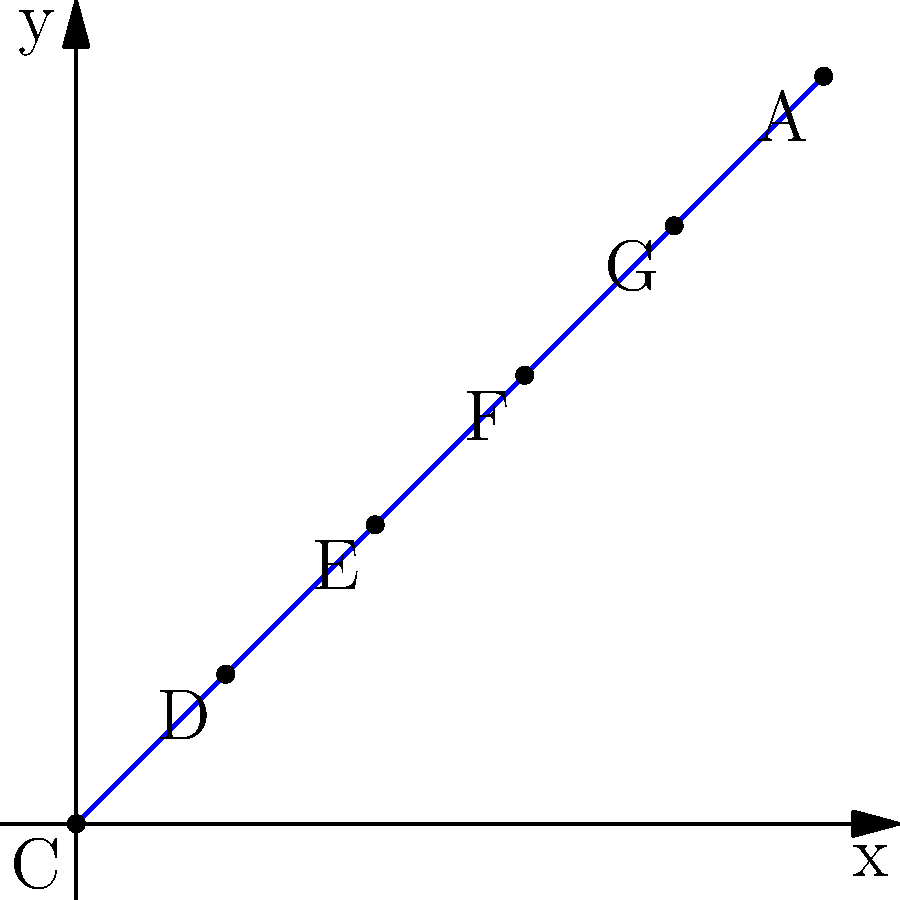Onyeka Onwenu's hit song "One Love" is represented by a polynomial equation whose roots correspond to musical notes on a staff. If the roots of the polynomial are represented by the points on the graph, and each consecutive note is one semitone apart, which of Onyeka's songs would have a polynomial with roots corresponding to the notes C, E, and G? To solve this problem, we need to follow these steps:

1) First, we need to understand the graph. The x-axis represents the position of the note, and the y-axis represents the pitch.

2) We can see that the notes are arranged in order: C, D, E, F, G, A.

3) The question asks for a polynomial with roots at C, E, and G. On the graph, these correspond to the points (0,0), (2,2), and (4,4).

4) In musical terms, the interval between C and E is a major third (4 semitones), and the interval between E and G is a minor third (3 semitones). Together, they form a major triad chord.

5) The major triad chord C-E-G is a common chord in many of Onyeka Onwenu's songs, but it's particularly prominent in her song "Ekwe".

6) The polynomial that would have these roots would be of the form:

   $$(x-0)(x-2)(x-4) = x^3 - 6x^2 + 8x$$

   This polynomial would have roots at x = 0, 2, and 4, corresponding to the notes C, E, and G.
Answer: Ekwe 